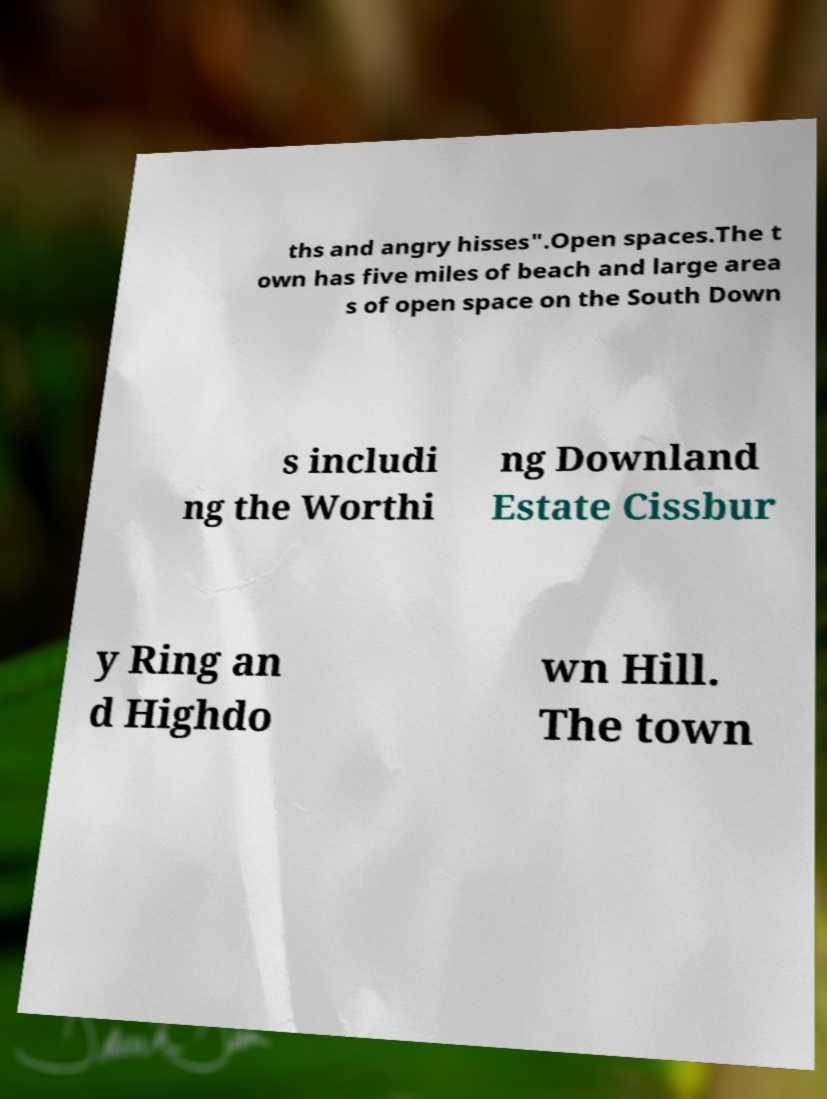What messages or text are displayed in this image? I need them in a readable, typed format. ths and angry hisses".Open spaces.The t own has five miles of beach and large area s of open space on the South Down s includi ng the Worthi ng Downland Estate Cissbur y Ring an d Highdo wn Hill. The town 